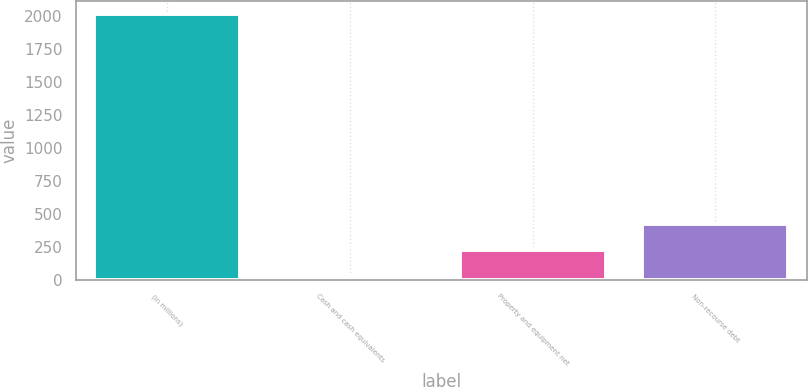<chart> <loc_0><loc_0><loc_500><loc_500><bar_chart><fcel>(in millions)<fcel>Cash and cash equivalents<fcel>Property and equipment net<fcel>Non-recourse debt<nl><fcel>2014<fcel>26<fcel>224.8<fcel>423.6<nl></chart> 